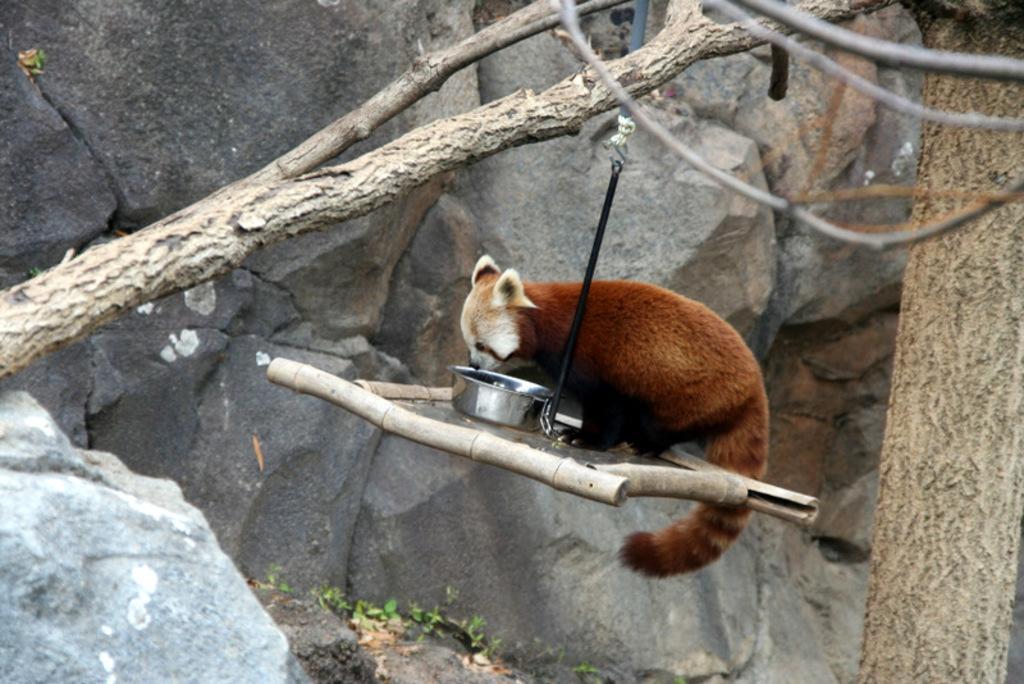Can you describe this image briefly? In this image I can see a tree trunk, few branches, few sticks, a red panda and a container. I can also see a black colour belt in the centre of the image and on the bottom side I can see green colour leaves. 